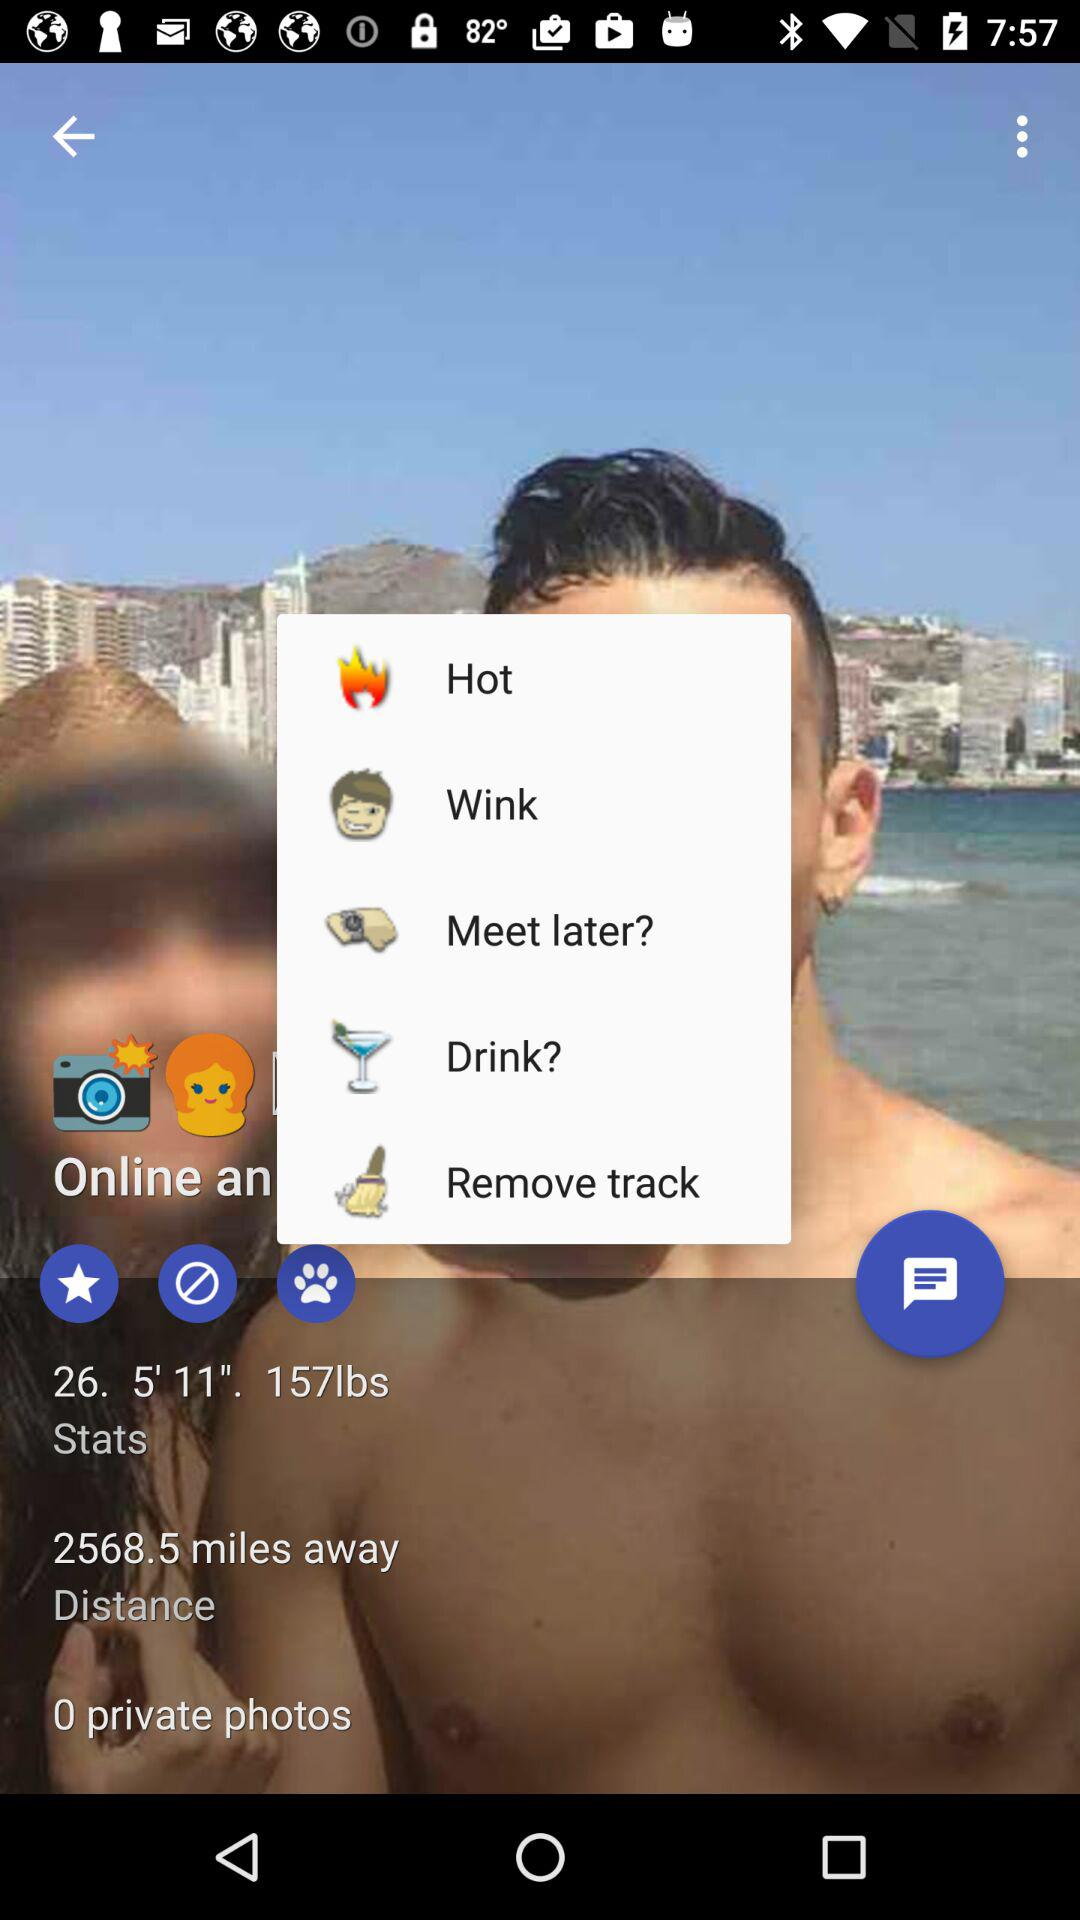What is the height? The height is 5'11". 